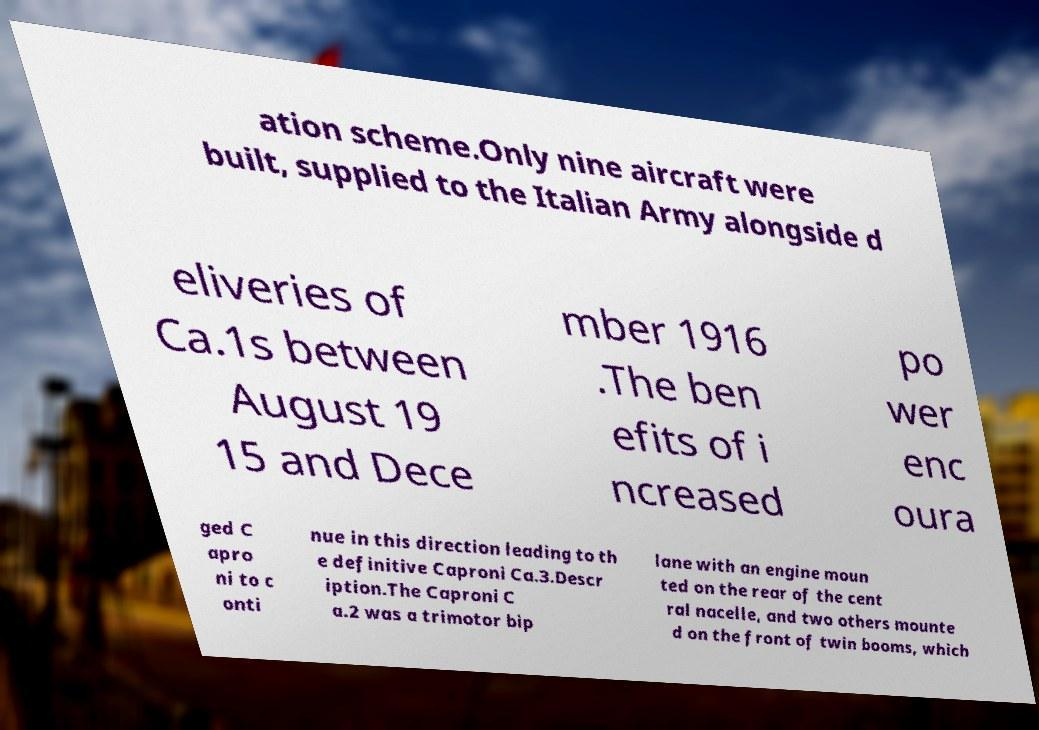For documentation purposes, I need the text within this image transcribed. Could you provide that? ation scheme.Only nine aircraft were built, supplied to the Italian Army alongside d eliveries of Ca.1s between August 19 15 and Dece mber 1916 .The ben efits of i ncreased po wer enc oura ged C apro ni to c onti nue in this direction leading to th e definitive Caproni Ca.3.Descr iption.The Caproni C a.2 was a trimotor bip lane with an engine moun ted on the rear of the cent ral nacelle, and two others mounte d on the front of twin booms, which 